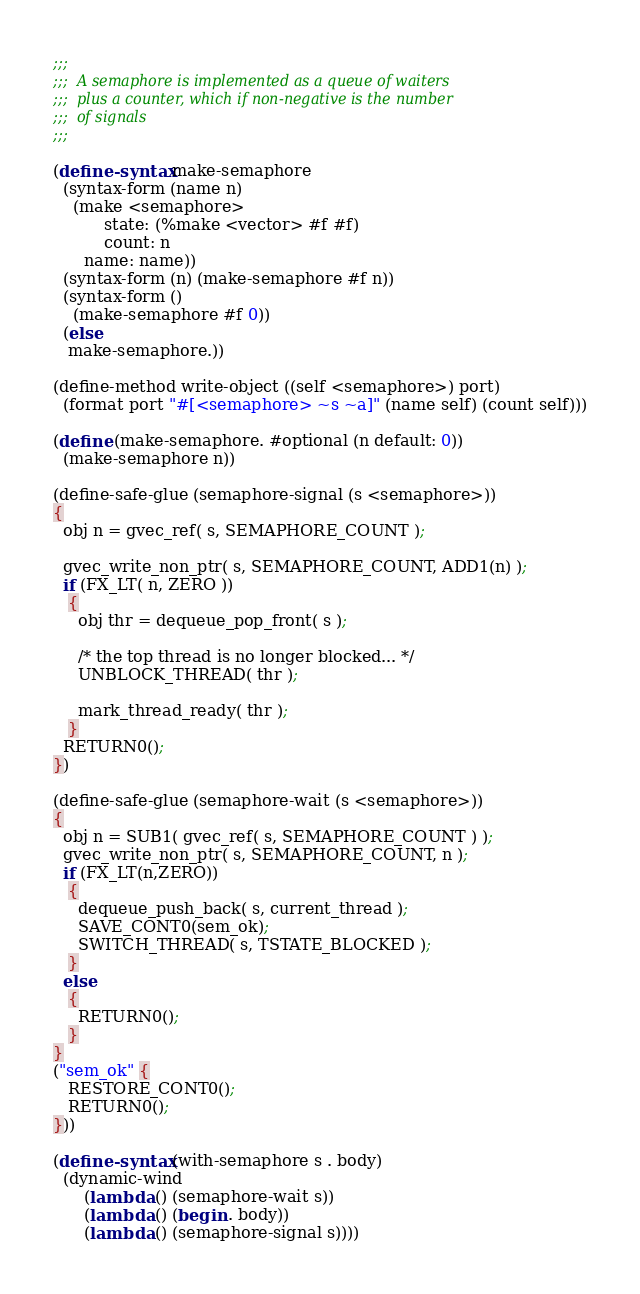Convert code to text. <code><loc_0><loc_0><loc_500><loc_500><_Scheme_>;;;
;;;  A semaphore is implemented as a queue of waiters
;;;  plus a counter, which if non-negative is the number
;;;  of signals
;;;

(define-syntax make-semaphore
  (syntax-form (name n)
    (make <semaphore>
          state: (%make <vector> #f #f)
          count: n
	  name: name))
  (syntax-form (n) (make-semaphore #f n))
  (syntax-form ()
    (make-semaphore #f 0))
  (else
   make-semaphore.))

(define-method write-object ((self <semaphore>) port)
  (format port "#[<semaphore> ~s ~a]" (name self) (count self)))

(define (make-semaphore. #optional (n default: 0))
  (make-semaphore n))

(define-safe-glue (semaphore-signal (s <semaphore>))
{
  obj n = gvec_ref( s, SEMAPHORE_COUNT );

  gvec_write_non_ptr( s, SEMAPHORE_COUNT, ADD1(n) );
  if (FX_LT( n, ZERO ))
   {
     obj thr = dequeue_pop_front( s );

     /* the top thread is no longer blocked... */
     UNBLOCK_THREAD( thr );

     mark_thread_ready( thr );
   }
  RETURN0();
})

(define-safe-glue (semaphore-wait (s <semaphore>))
{
  obj n = SUB1( gvec_ref( s, SEMAPHORE_COUNT ) );
  gvec_write_non_ptr( s, SEMAPHORE_COUNT, n );
  if (FX_LT(n,ZERO))
   {
     dequeue_push_back( s, current_thread );
     SAVE_CONT0(sem_ok);
     SWITCH_THREAD( s, TSTATE_BLOCKED );
   }
  else
   {
     RETURN0();
   }
}
("sem_ok" {
   RESTORE_CONT0();
   RETURN0();
}))

(define-syntax (with-semaphore s . body)
  (dynamic-wind
      (lambda () (semaphore-wait s))
      (lambda () (begin . body))
      (lambda () (semaphore-signal s))))
</code> 